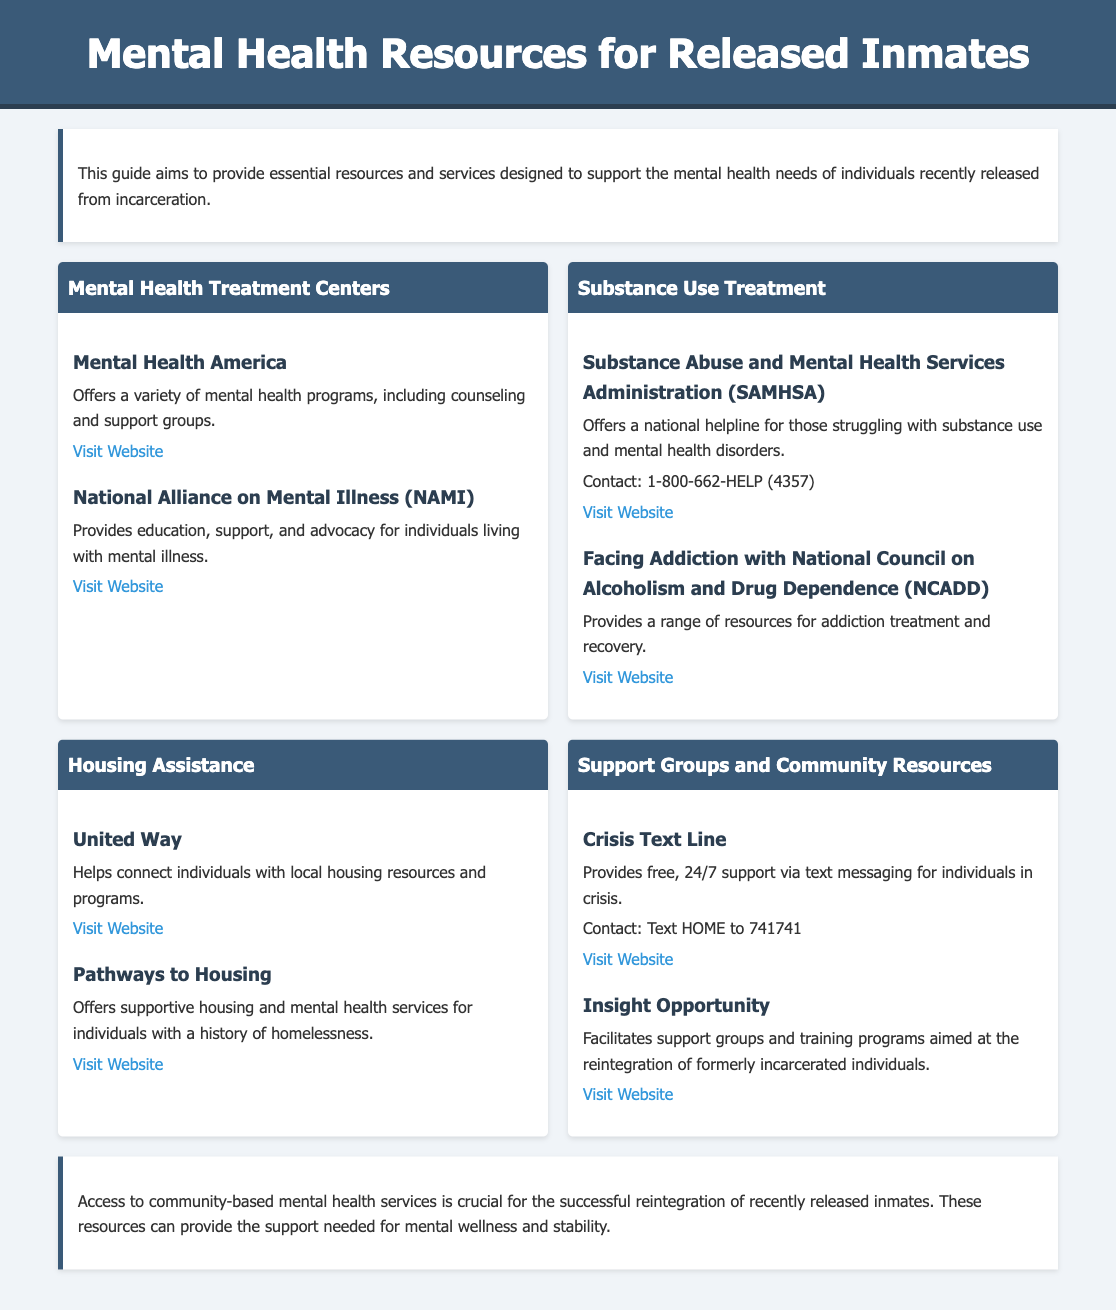What is the title of the document? The title of the document is displayed prominently in the header section, summarizing its content about mental health resources.
Answer: Mental Health Resources for Released Inmates How many mental health treatment centers are listed? The document contains a section specifically for mental health treatment centers, detailing the names of these centers.
Answer: 2 What is the contact number for SAMHSA? The contact number provided in the resource for SAMHSA is clearly mentioned under the Substance Use Treatment section.
Answer: 1-800-662-HELP (4357) Which organization offers supportive housing and mental health services? The document specifies an organization in the Housing Assistance section that provides these services.
Answer: Pathways to Housing What service does the Crisis Text Line provide? The description under the Crisis Text Line indicates what type of support is available through this resource.
Answer: Free, 24/7 support via text messaging What is a key benefit of accessing community-based mental health services? The conclusion summarizes the significance of these services for the well-being of recently released inmates.
Answer: Successful reintegration What type of resource does Insight Opportunity facilitate? The document mentions a specific type of program provided by Insight Opportunity aimed at formerly incarcerated individuals.
Answer: Support groups and training programs Which alliance provides education and advocacy for mental illness? The document lists an organization that specifically focuses on education and support for individuals with mental illness.
Answer: National Alliance on Mental Illness (NAMI) What type of assistance does United Way help with? The introduction to the resource describes the function of United Way in relation to housing.
Answer: Housing assistance 